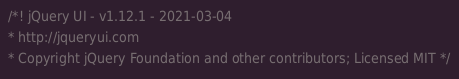<code> <loc_0><loc_0><loc_500><loc_500><_CSS_>/*! jQuery UI - v1.12.1 - 2021-03-04
* http://jqueryui.com
* Copyright jQuery Foundation and other contributors; Licensed MIT */
</code> 